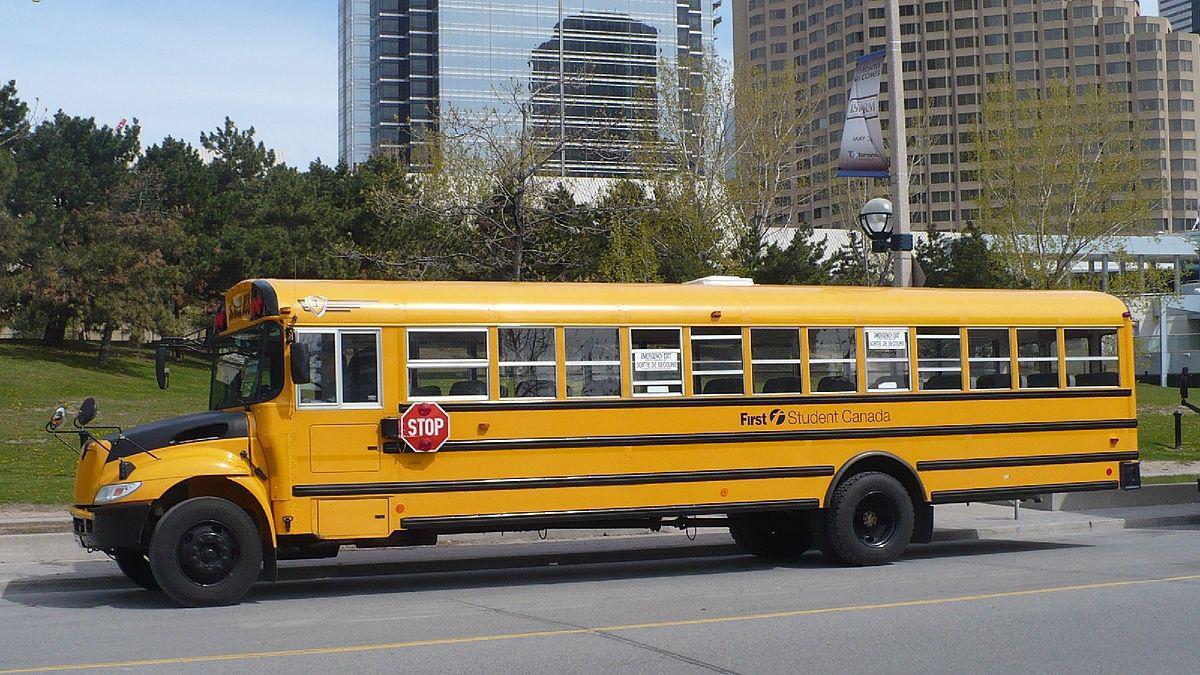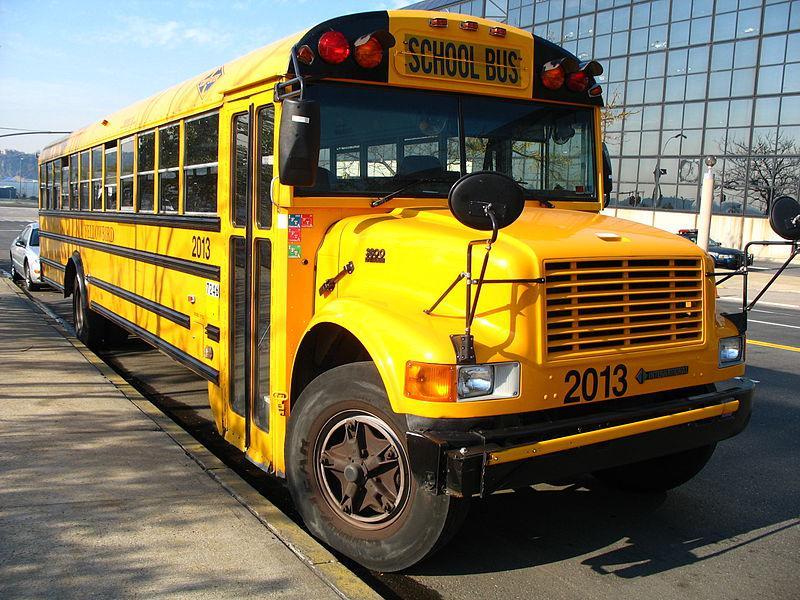The first image is the image on the left, the second image is the image on the right. Considering the images on both sides, is "A short school bus with no more than four windows in the body side has standard wide turning mirrors at the front of the hood." valid? Answer yes or no. No. The first image is the image on the left, the second image is the image on the right. For the images displayed, is the sentence "Buses are lined up side by side in at least one of the images." factually correct? Answer yes or no. No. 